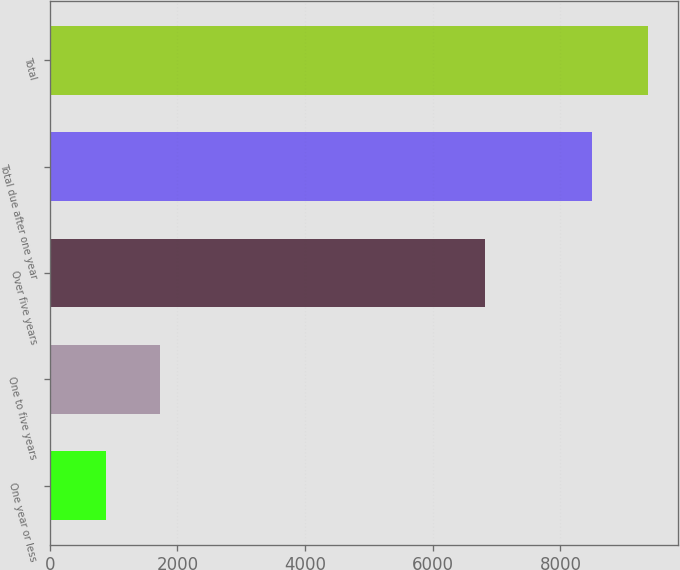Convert chart to OTSL. <chart><loc_0><loc_0><loc_500><loc_500><bar_chart><fcel>One year or less<fcel>One to five years<fcel>Over five years<fcel>Total due after one year<fcel>Total<nl><fcel>877.1<fcel>1726.56<fcel>6815<fcel>8494.6<fcel>9371.7<nl></chart> 